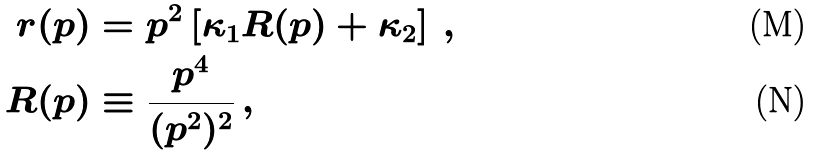Convert formula to latex. <formula><loc_0><loc_0><loc_500><loc_500>r ( p ) & = p ^ { 2 } \left [ \kappa _ { 1 } R ( p ) + \kappa _ { 2 } \right ] \, , \\ R ( p ) & \equiv \frac { p ^ { 4 } } { ( p ^ { 2 } ) ^ { 2 } } \, ,</formula> 